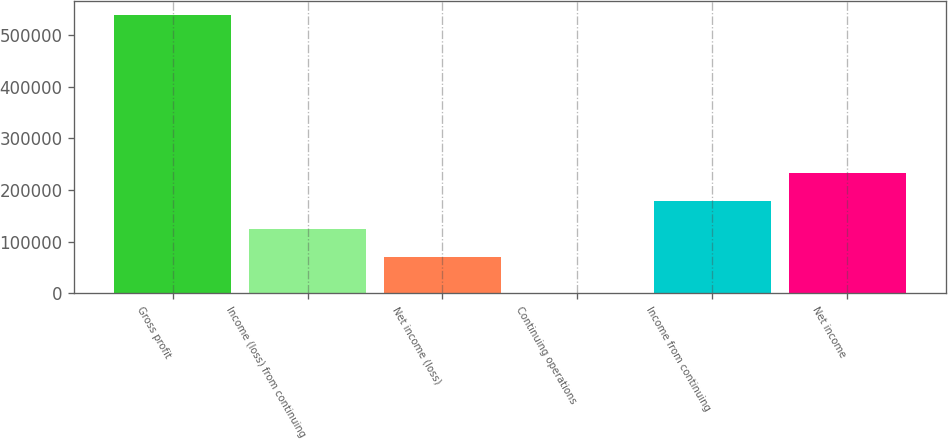Convert chart. <chart><loc_0><loc_0><loc_500><loc_500><bar_chart><fcel>Gross profit<fcel>Income (loss) from continuing<fcel>Net income (loss)<fcel>Continuing operations<fcel>Income from continuing<fcel>Net income<nl><fcel>539531<fcel>124570<fcel>70617<fcel>0.2<fcel>178523<fcel>232476<nl></chart> 